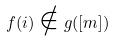<formula> <loc_0><loc_0><loc_500><loc_500>f ( i ) \notin g ( [ m ] )</formula> 